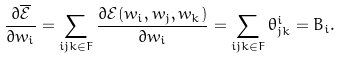<formula> <loc_0><loc_0><loc_500><loc_500>\frac { \partial \overline { \mathcal { E } } } { \partial w _ { i } } = \sum _ { i j k \in F } \frac { \partial \mathcal { E } ( w _ { i } , w _ { j } , w _ { k } ) } { \partial w _ { i } } = \sum _ { i j k \in F } \theta ^ { i } _ { j k } = B _ { i } .</formula> 